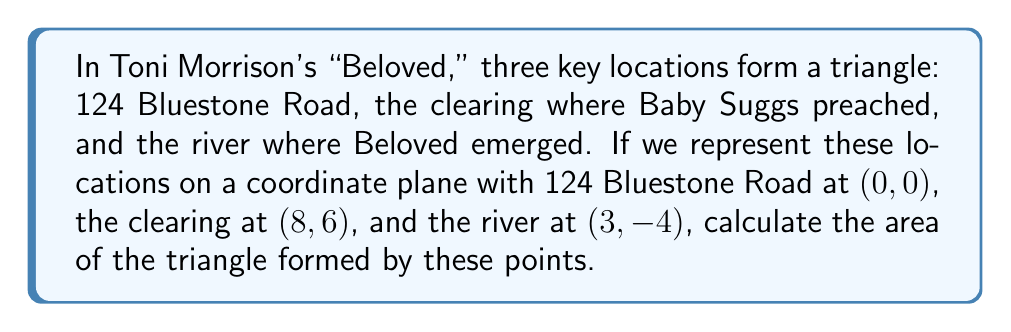Solve this math problem. To calculate the area of a triangle given the coordinates of its vertices, we can use the formula:

$$\text{Area} = \frac{1}{2}|x_1(y_2 - y_3) + x_2(y_3 - y_1) + x_3(y_1 - y_2)|$$

Where $(x_1, y_1)$, $(x_2, y_2)$, and $(x_3, y_3)$ are the coordinates of the three vertices.

Let's assign our points:
$(x_1, y_1) = (0, 0)$ (124 Bluestone Road)
$(x_2, y_2) = (8, 6)$ (the clearing)
$(x_3, y_3) = (3, -4)$ (the river)

Now, let's substitute these values into the formula:

$$\begin{align*}
\text{Area} &= \frac{1}{2}|0(6 - (-4)) + 8((-4) - 0) + 3(0 - 6)| \\
&= \frac{1}{2}|0(10) + 8(-4) + 3(-6)| \\
&= \frac{1}{2}|0 - 32 - 18| \\
&= \frac{1}{2}|-50| \\
&= \frac{1}{2}(50) \\
&= 25
\end{align*}$$

Therefore, the area of the triangle is 25 square units.

[asy]
unitsize(1cm);
draw((-1,-5)--(9,7), gray);
draw((-1,-5)--(4,7), gray);
draw((8,6)--(3,-4), gray);
dot((0,0));
dot((8,6));
dot((3,-4));
label("124 Bluestone Road (0,0)", (0,0), SE);
label("Clearing (8,6)", (8,6), NE);
label("River (3,-4)", (3,-4), SW);
[/asy]
Answer: 25 square units 